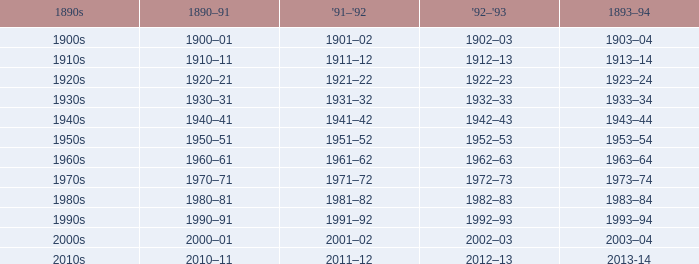Could you parse the entire table? {'header': ['1890s', '1890–91', "'91–'92", "'92–'93", '1893–94'], 'rows': [['1900s', '1900–01', '1901–02', '1902–03', '1903–04'], ['1910s', '1910–11', '1911–12', '1912–13', '1913–14'], ['1920s', '1920–21', '1921–22', '1922–23', '1923–24'], ['1930s', '1930–31', '1931–32', '1932–33', '1933–34'], ['1940s', '1940–41', '1941–42', '1942–43', '1943–44'], ['1950s', '1950–51', '1951–52', '1952–53', '1953–54'], ['1960s', '1960–61', '1961–62', '1962–63', '1963–64'], ['1970s', '1970–71', '1971–72', '1972–73', '1973–74'], ['1980s', '1980–81', '1981–82', '1982–83', '1983–84'], ['1990s', '1990–91', '1991–92', '1992–93', '1993–94'], ['2000s', '2000–01', '2001–02', '2002–03', '2003–04'], ['2010s', '2010–11', '2011–12', '2012–13', '2013-14']]} What is the year from 1892-93 that has the 1890s to the 1940s? 1942–43. 